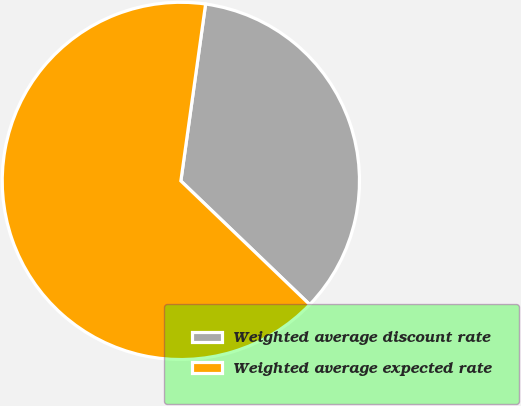Convert chart to OTSL. <chart><loc_0><loc_0><loc_500><loc_500><pie_chart><fcel>Weighted average discount rate<fcel>Weighted average expected rate<nl><fcel>34.96%<fcel>65.04%<nl></chart> 